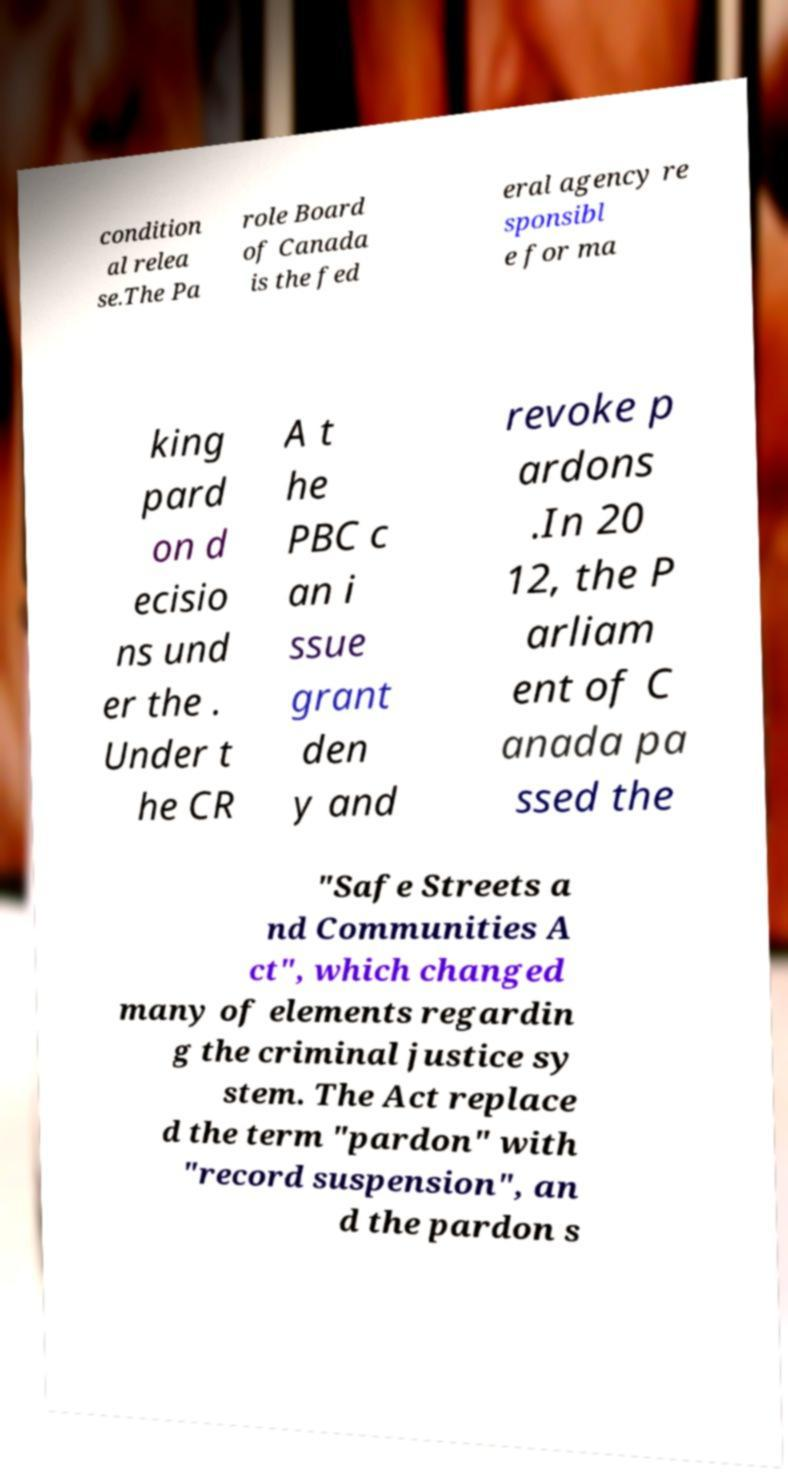Please identify and transcribe the text found in this image. condition al relea se.The Pa role Board of Canada is the fed eral agency re sponsibl e for ma king pard on d ecisio ns und er the . Under t he CR A t he PBC c an i ssue grant den y and revoke p ardons .In 20 12, the P arliam ent of C anada pa ssed the "Safe Streets a nd Communities A ct", which changed many of elements regardin g the criminal justice sy stem. The Act replace d the term "pardon" with "record suspension", an d the pardon s 